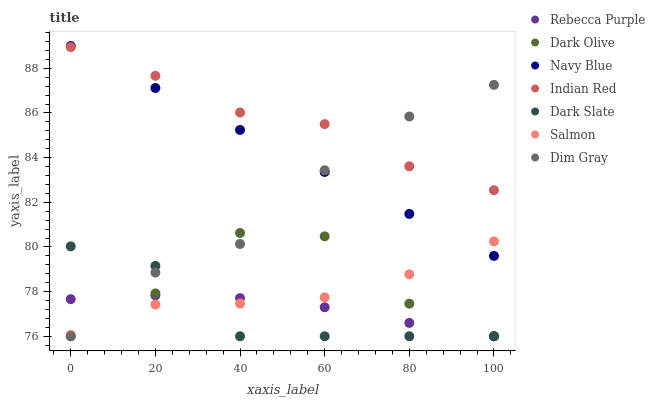Does Dark Slate have the minimum area under the curve?
Answer yes or no. Yes. Does Indian Red have the maximum area under the curve?
Answer yes or no. Yes. Does Navy Blue have the minimum area under the curve?
Answer yes or no. No. Does Navy Blue have the maximum area under the curve?
Answer yes or no. No. Is Navy Blue the smoothest?
Answer yes or no. Yes. Is Dark Olive the roughest?
Answer yes or no. Yes. Is Dark Olive the smoothest?
Answer yes or no. No. Is Navy Blue the roughest?
Answer yes or no. No. Does Dim Gray have the lowest value?
Answer yes or no. Yes. Does Navy Blue have the lowest value?
Answer yes or no. No. Does Navy Blue have the highest value?
Answer yes or no. Yes. Does Dark Olive have the highest value?
Answer yes or no. No. Is Dark Olive less than Indian Red?
Answer yes or no. Yes. Is Indian Red greater than Dark Slate?
Answer yes or no. Yes. Does Dark Slate intersect Dark Olive?
Answer yes or no. Yes. Is Dark Slate less than Dark Olive?
Answer yes or no. No. Is Dark Slate greater than Dark Olive?
Answer yes or no. No. Does Dark Olive intersect Indian Red?
Answer yes or no. No. 